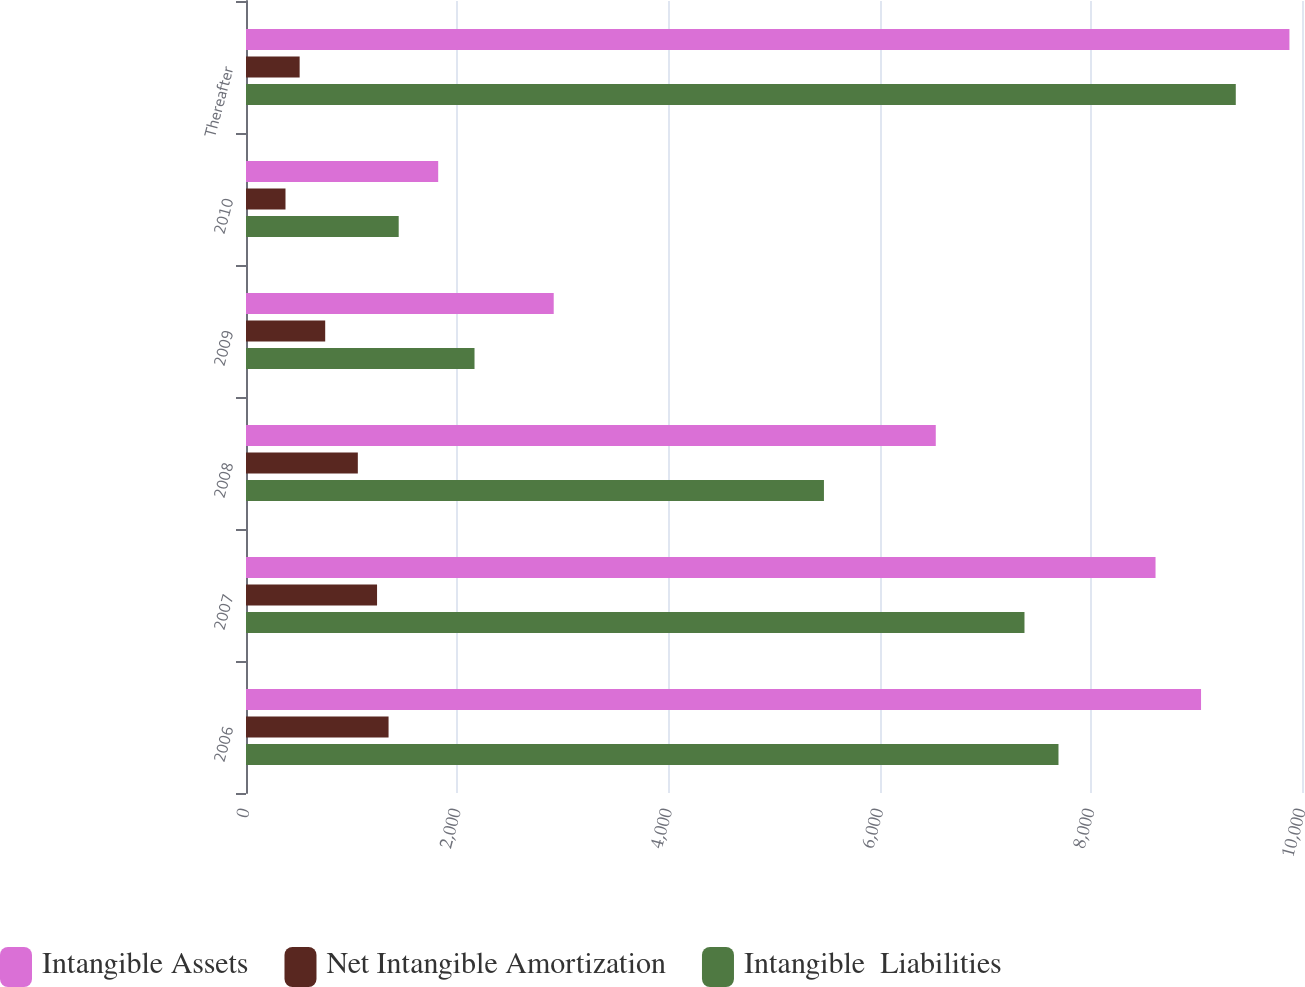Convert chart to OTSL. <chart><loc_0><loc_0><loc_500><loc_500><stacked_bar_chart><ecel><fcel>2006<fcel>2007<fcel>2008<fcel>2009<fcel>2010<fcel>Thereafter<nl><fcel>Intangible Assets<fcel>9044<fcel>8613<fcel>6532<fcel>2914<fcel>1820<fcel>9881<nl><fcel>Net Intangible Amortization<fcel>1350<fcel>1241<fcel>1059<fcel>750<fcel>374<fcel>508<nl><fcel>Intangible  Liabilities<fcel>7694<fcel>7372<fcel>5473<fcel>2164<fcel>1446<fcel>9373<nl></chart> 